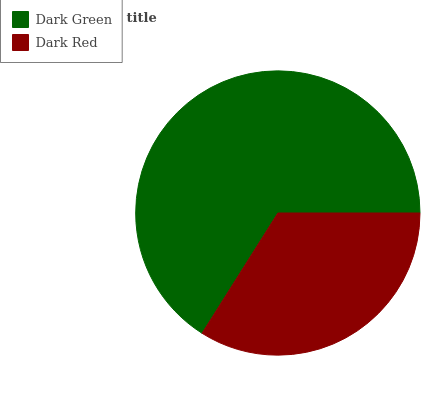Is Dark Red the minimum?
Answer yes or no. Yes. Is Dark Green the maximum?
Answer yes or no. Yes. Is Dark Red the maximum?
Answer yes or no. No. Is Dark Green greater than Dark Red?
Answer yes or no. Yes. Is Dark Red less than Dark Green?
Answer yes or no. Yes. Is Dark Red greater than Dark Green?
Answer yes or no. No. Is Dark Green less than Dark Red?
Answer yes or no. No. Is Dark Green the high median?
Answer yes or no. Yes. Is Dark Red the low median?
Answer yes or no. Yes. Is Dark Red the high median?
Answer yes or no. No. Is Dark Green the low median?
Answer yes or no. No. 